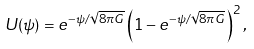<formula> <loc_0><loc_0><loc_500><loc_500>U ( \psi ) = e ^ { - \psi / \sqrt { 8 \pi G } } \left ( 1 - e ^ { - \psi / \sqrt { 8 \pi G } } \right ) ^ { 2 } ,</formula> 